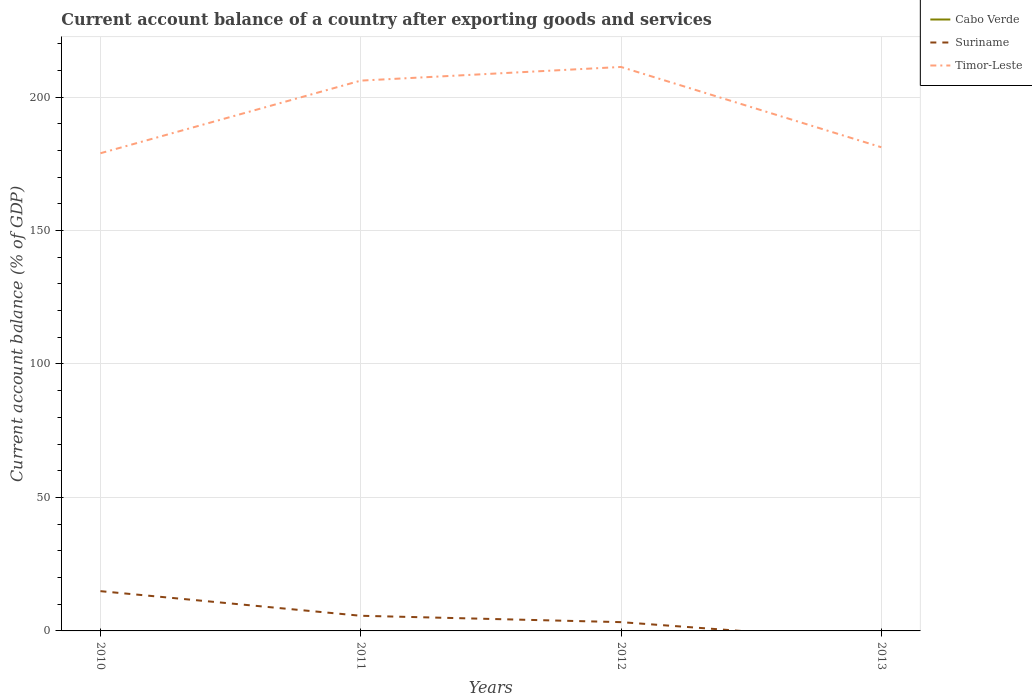How many different coloured lines are there?
Give a very brief answer. 2. Is the number of lines equal to the number of legend labels?
Ensure brevity in your answer.  No. Across all years, what is the maximum account balance in Suriname?
Your answer should be compact. 0. What is the total account balance in Timor-Leste in the graph?
Your answer should be compact. -5.12. What is the difference between the highest and the second highest account balance in Suriname?
Your answer should be very brief. 14.9. What is the difference between two consecutive major ticks on the Y-axis?
Your answer should be very brief. 50. Does the graph contain any zero values?
Keep it short and to the point. Yes. Does the graph contain grids?
Provide a succinct answer. Yes. How are the legend labels stacked?
Provide a succinct answer. Vertical. What is the title of the graph?
Your answer should be compact. Current account balance of a country after exporting goods and services. Does "Other small states" appear as one of the legend labels in the graph?
Give a very brief answer. No. What is the label or title of the Y-axis?
Your response must be concise. Current account balance (% of GDP). What is the Current account balance (% of GDP) of Cabo Verde in 2010?
Your answer should be very brief. 0. What is the Current account balance (% of GDP) of Suriname in 2010?
Keep it short and to the point. 14.9. What is the Current account balance (% of GDP) in Timor-Leste in 2010?
Provide a succinct answer. 178.95. What is the Current account balance (% of GDP) in Suriname in 2011?
Your response must be concise. 5.68. What is the Current account balance (% of GDP) in Timor-Leste in 2011?
Give a very brief answer. 206.16. What is the Current account balance (% of GDP) of Cabo Verde in 2012?
Keep it short and to the point. 0. What is the Current account balance (% of GDP) of Suriname in 2012?
Your answer should be compact. 3.29. What is the Current account balance (% of GDP) of Timor-Leste in 2012?
Offer a very short reply. 211.28. What is the Current account balance (% of GDP) in Cabo Verde in 2013?
Keep it short and to the point. 0. What is the Current account balance (% of GDP) of Timor-Leste in 2013?
Your answer should be very brief. 181.2. Across all years, what is the maximum Current account balance (% of GDP) of Suriname?
Your answer should be very brief. 14.9. Across all years, what is the maximum Current account balance (% of GDP) of Timor-Leste?
Your response must be concise. 211.28. Across all years, what is the minimum Current account balance (% of GDP) of Suriname?
Make the answer very short. 0. Across all years, what is the minimum Current account balance (% of GDP) in Timor-Leste?
Ensure brevity in your answer.  178.95. What is the total Current account balance (% of GDP) of Suriname in the graph?
Your answer should be compact. 23.87. What is the total Current account balance (% of GDP) of Timor-Leste in the graph?
Offer a terse response. 777.58. What is the difference between the Current account balance (% of GDP) of Suriname in 2010 and that in 2011?
Your answer should be very brief. 9.22. What is the difference between the Current account balance (% of GDP) in Timor-Leste in 2010 and that in 2011?
Make the answer very short. -27.21. What is the difference between the Current account balance (% of GDP) of Suriname in 2010 and that in 2012?
Offer a very short reply. 11.61. What is the difference between the Current account balance (% of GDP) of Timor-Leste in 2010 and that in 2012?
Provide a succinct answer. -32.33. What is the difference between the Current account balance (% of GDP) in Timor-Leste in 2010 and that in 2013?
Your answer should be very brief. -2.25. What is the difference between the Current account balance (% of GDP) in Suriname in 2011 and that in 2012?
Offer a terse response. 2.39. What is the difference between the Current account balance (% of GDP) of Timor-Leste in 2011 and that in 2012?
Your response must be concise. -5.12. What is the difference between the Current account balance (% of GDP) of Timor-Leste in 2011 and that in 2013?
Your answer should be compact. 24.95. What is the difference between the Current account balance (% of GDP) in Timor-Leste in 2012 and that in 2013?
Your answer should be compact. 30.07. What is the difference between the Current account balance (% of GDP) of Suriname in 2010 and the Current account balance (% of GDP) of Timor-Leste in 2011?
Your answer should be compact. -191.26. What is the difference between the Current account balance (% of GDP) in Suriname in 2010 and the Current account balance (% of GDP) in Timor-Leste in 2012?
Your answer should be compact. -196.38. What is the difference between the Current account balance (% of GDP) of Suriname in 2010 and the Current account balance (% of GDP) of Timor-Leste in 2013?
Your answer should be compact. -166.3. What is the difference between the Current account balance (% of GDP) of Suriname in 2011 and the Current account balance (% of GDP) of Timor-Leste in 2012?
Your response must be concise. -205.6. What is the difference between the Current account balance (% of GDP) of Suriname in 2011 and the Current account balance (% of GDP) of Timor-Leste in 2013?
Make the answer very short. -175.52. What is the difference between the Current account balance (% of GDP) of Suriname in 2012 and the Current account balance (% of GDP) of Timor-Leste in 2013?
Your response must be concise. -177.91. What is the average Current account balance (% of GDP) of Cabo Verde per year?
Your answer should be very brief. 0. What is the average Current account balance (% of GDP) of Suriname per year?
Provide a succinct answer. 5.97. What is the average Current account balance (% of GDP) of Timor-Leste per year?
Provide a succinct answer. 194.39. In the year 2010, what is the difference between the Current account balance (% of GDP) in Suriname and Current account balance (% of GDP) in Timor-Leste?
Provide a succinct answer. -164.05. In the year 2011, what is the difference between the Current account balance (% of GDP) of Suriname and Current account balance (% of GDP) of Timor-Leste?
Your answer should be compact. -200.48. In the year 2012, what is the difference between the Current account balance (% of GDP) of Suriname and Current account balance (% of GDP) of Timor-Leste?
Your answer should be very brief. -207.98. What is the ratio of the Current account balance (% of GDP) in Suriname in 2010 to that in 2011?
Your answer should be compact. 2.62. What is the ratio of the Current account balance (% of GDP) in Timor-Leste in 2010 to that in 2011?
Your answer should be very brief. 0.87. What is the ratio of the Current account balance (% of GDP) in Suriname in 2010 to that in 2012?
Offer a very short reply. 4.53. What is the ratio of the Current account balance (% of GDP) of Timor-Leste in 2010 to that in 2012?
Offer a very short reply. 0.85. What is the ratio of the Current account balance (% of GDP) of Timor-Leste in 2010 to that in 2013?
Offer a very short reply. 0.99. What is the ratio of the Current account balance (% of GDP) of Suriname in 2011 to that in 2012?
Your answer should be very brief. 1.73. What is the ratio of the Current account balance (% of GDP) of Timor-Leste in 2011 to that in 2012?
Provide a succinct answer. 0.98. What is the ratio of the Current account balance (% of GDP) in Timor-Leste in 2011 to that in 2013?
Your answer should be compact. 1.14. What is the ratio of the Current account balance (% of GDP) in Timor-Leste in 2012 to that in 2013?
Your answer should be very brief. 1.17. What is the difference between the highest and the second highest Current account balance (% of GDP) of Suriname?
Your answer should be compact. 9.22. What is the difference between the highest and the second highest Current account balance (% of GDP) in Timor-Leste?
Provide a short and direct response. 5.12. What is the difference between the highest and the lowest Current account balance (% of GDP) of Suriname?
Offer a very short reply. 14.9. What is the difference between the highest and the lowest Current account balance (% of GDP) of Timor-Leste?
Your answer should be compact. 32.33. 